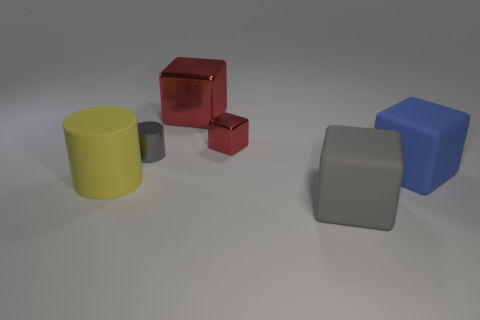Is the number of tiny red shiny things that are to the left of the big yellow object the same as the number of large metal things on the right side of the blue object?
Give a very brief answer. Yes. There is a gray thing that is in front of the tiny shiny object that is in front of the small metallic thing that is behind the tiny gray metallic cylinder; what is its shape?
Your answer should be very brief. Cube. Does the big block in front of the large yellow matte object have the same material as the gray object behind the blue matte thing?
Your answer should be very brief. No. What is the shape of the tiny thing right of the gray metallic cylinder?
Make the answer very short. Cube. Is the number of yellow rubber objects less than the number of red blocks?
Offer a terse response. Yes. There is a big yellow cylinder in front of the tiny shiny object in front of the small red thing; is there a thing on the right side of it?
Your answer should be compact. Yes. What number of shiny objects are gray cylinders or big yellow things?
Offer a very short reply. 1. Is the color of the big metallic block the same as the small shiny cube?
Offer a very short reply. Yes. How many things are behind the big rubber cylinder?
Offer a terse response. 4. How many objects are both on the right side of the tiny cylinder and behind the blue matte cube?
Keep it short and to the point. 2. 